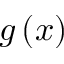Convert formula to latex. <formula><loc_0><loc_0><loc_500><loc_500>g \left ( x \right )</formula> 